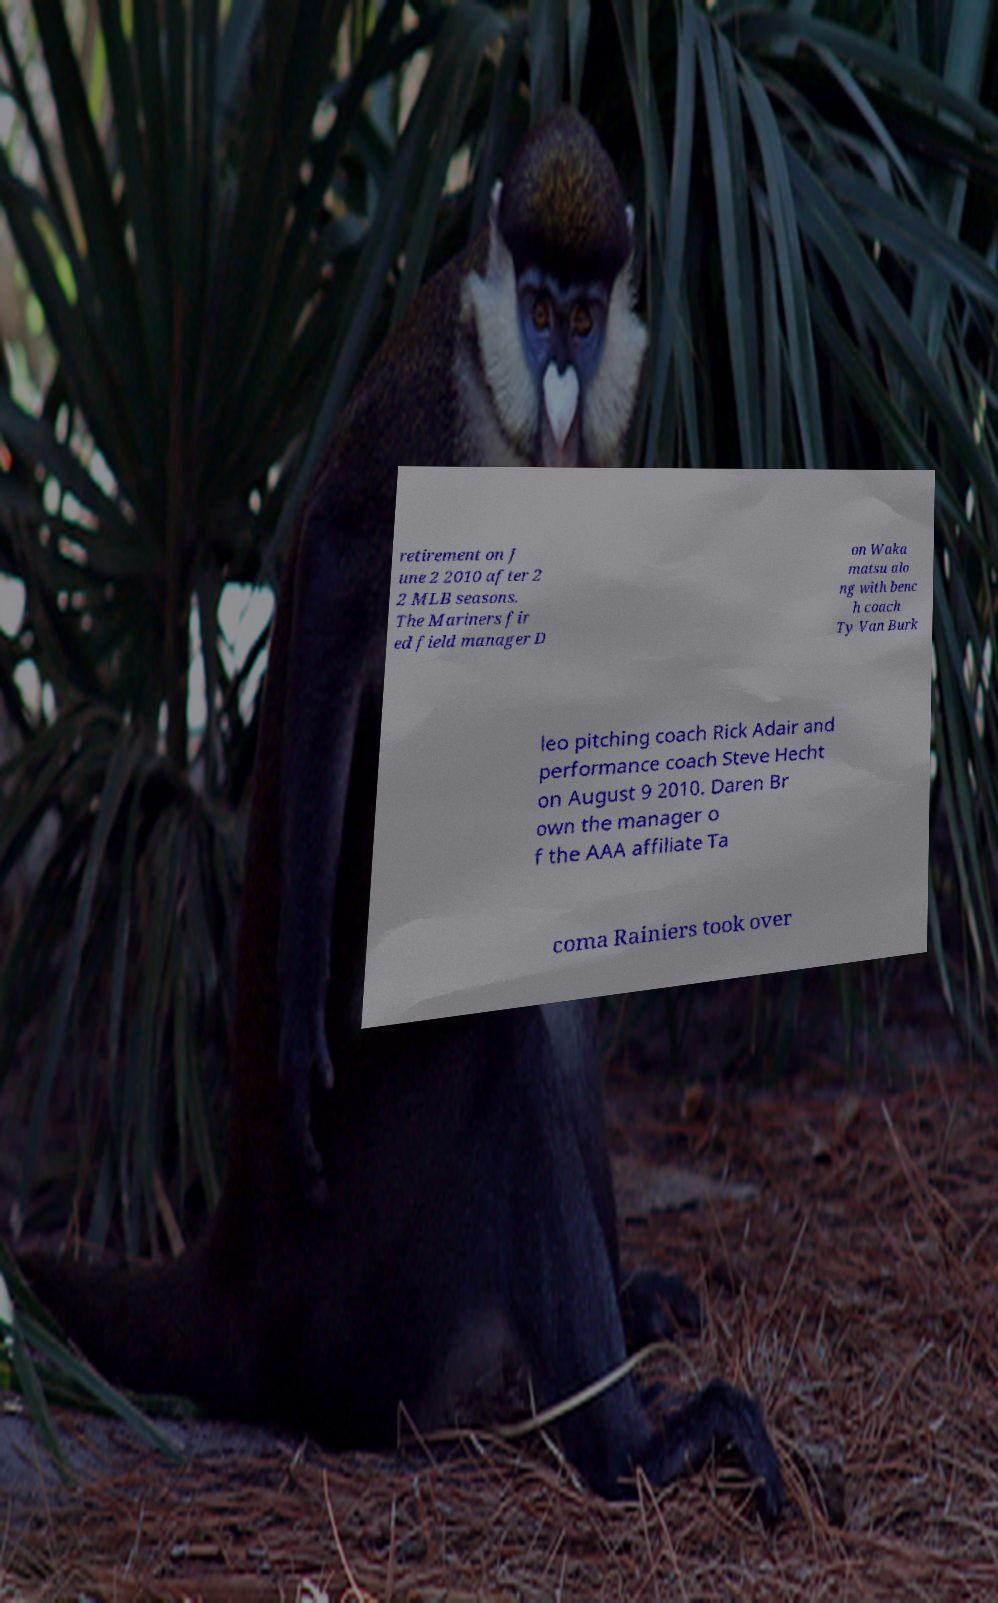Please read and relay the text visible in this image. What does it say? retirement on J une 2 2010 after 2 2 MLB seasons. The Mariners fir ed field manager D on Waka matsu alo ng with benc h coach Ty Van Burk leo pitching coach Rick Adair and performance coach Steve Hecht on August 9 2010. Daren Br own the manager o f the AAA affiliate Ta coma Rainiers took over 